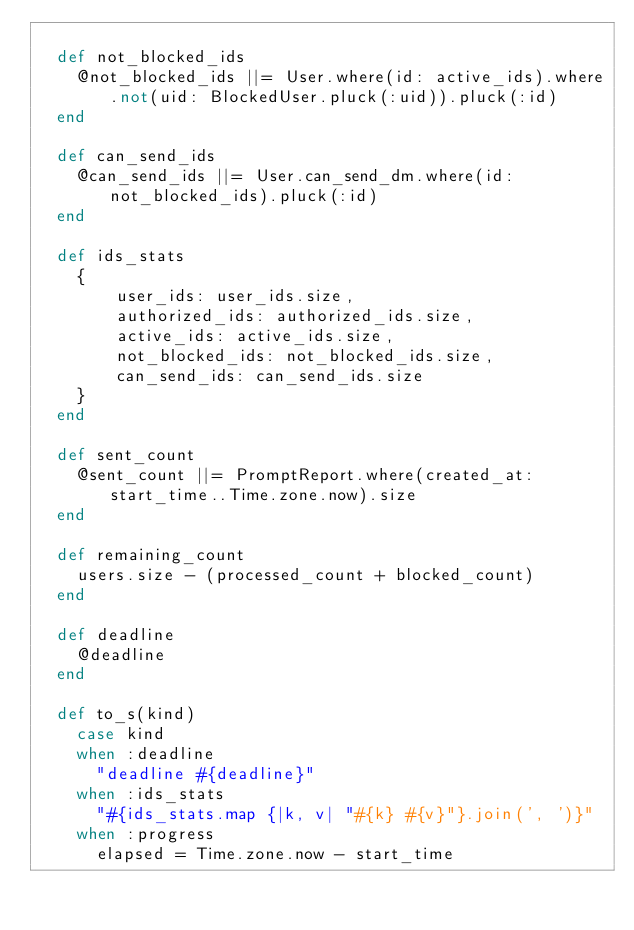Convert code to text. <code><loc_0><loc_0><loc_500><loc_500><_Ruby_>
  def not_blocked_ids
    @not_blocked_ids ||= User.where(id: active_ids).where.not(uid: BlockedUser.pluck(:uid)).pluck(:id)
  end

  def can_send_ids
    @can_send_ids ||= User.can_send_dm.where(id: not_blocked_ids).pluck(:id)
  end

  def ids_stats
    {
        user_ids: user_ids.size,
        authorized_ids: authorized_ids.size,
        active_ids: active_ids.size,
        not_blocked_ids: not_blocked_ids.size,
        can_send_ids: can_send_ids.size
    }
  end

  def sent_count
    @sent_count ||= PromptReport.where(created_at: start_time..Time.zone.now).size
  end

  def remaining_count
    users.size - (processed_count + blocked_count)
  end

  def deadline
    @deadline
  end

  def to_s(kind)
    case kind
    when :deadline
      "deadline #{deadline}"
    when :ids_stats
      "#{ids_stats.map {|k, v| "#{k} #{v}"}.join(', ')}"
    when :progress
      elapsed = Time.zone.now - start_time</code> 